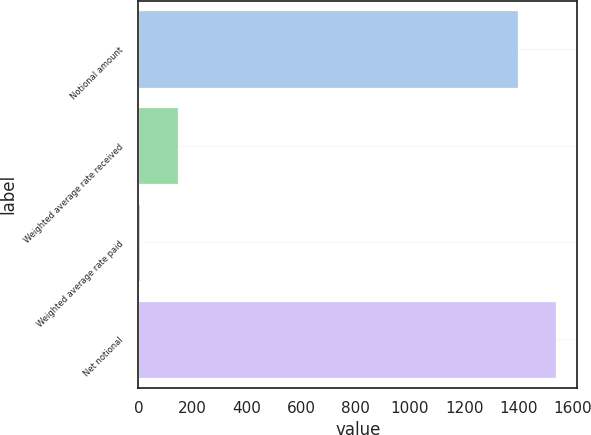<chart> <loc_0><loc_0><loc_500><loc_500><bar_chart><fcel>Notional amount<fcel>Weighted average rate received<fcel>Weighted average rate paid<fcel>Net notional<nl><fcel>1400<fcel>144.55<fcel>5.05<fcel>1539.49<nl></chart> 